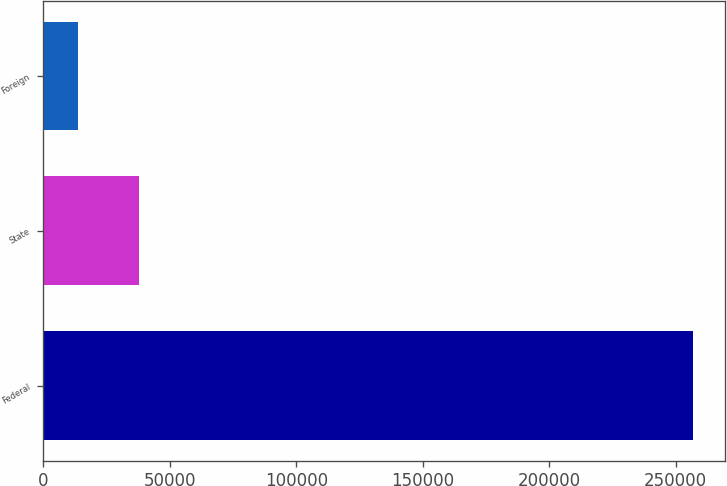Convert chart. <chart><loc_0><loc_0><loc_500><loc_500><bar_chart><fcel>Federal<fcel>State<fcel>Foreign<nl><fcel>256748<fcel>37984.1<fcel>13677<nl></chart> 